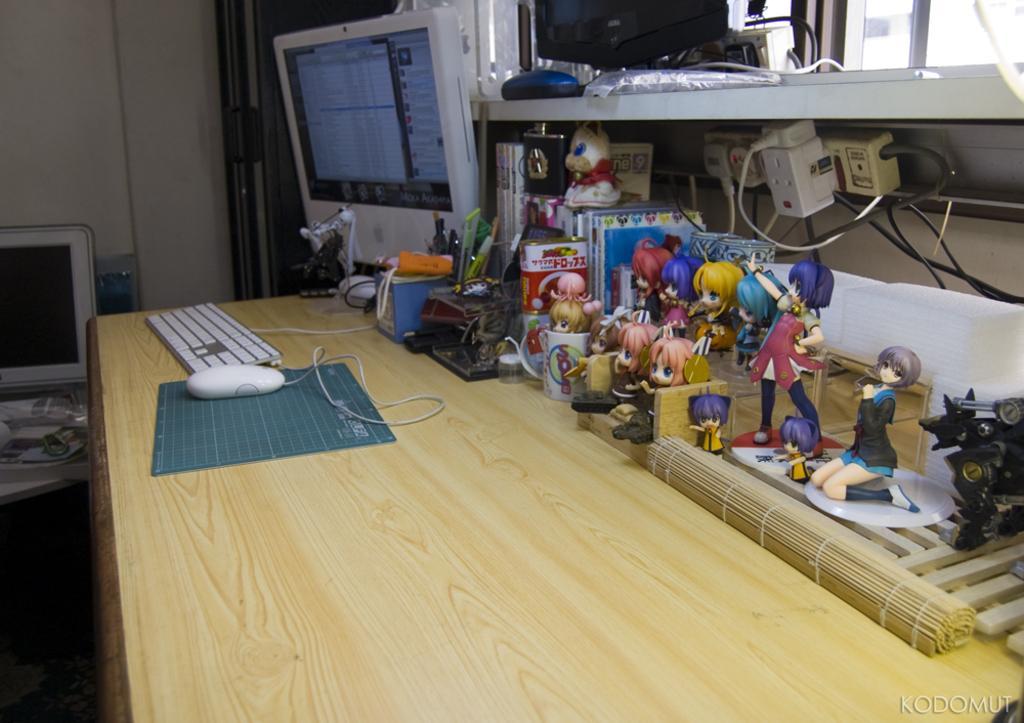Describe this image in one or two sentences. This is a wall. These are screens. On the table we can see Keyboard, mouse, mouse pad, different types of dolls. These are sockets. Here we can see a window. 